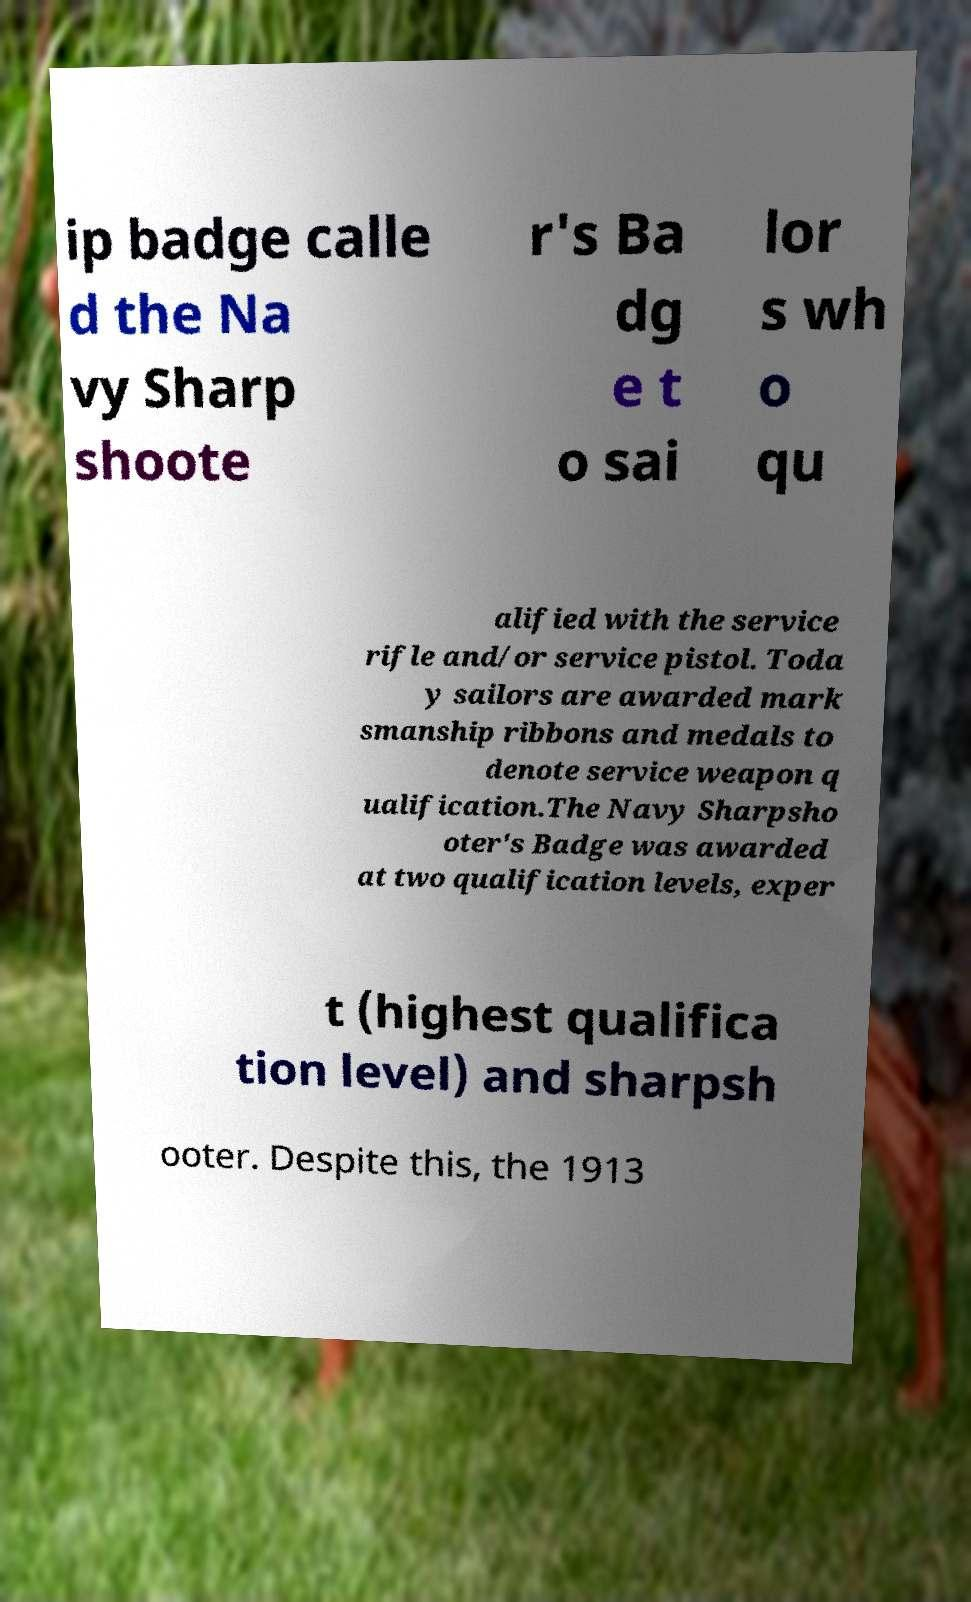Could you assist in decoding the text presented in this image and type it out clearly? ip badge calle d the Na vy Sharp shoote r's Ba dg e t o sai lor s wh o qu alified with the service rifle and/or service pistol. Toda y sailors are awarded mark smanship ribbons and medals to denote service weapon q ualification.The Navy Sharpsho oter's Badge was awarded at two qualification levels, exper t (highest qualifica tion level) and sharpsh ooter. Despite this, the 1913 